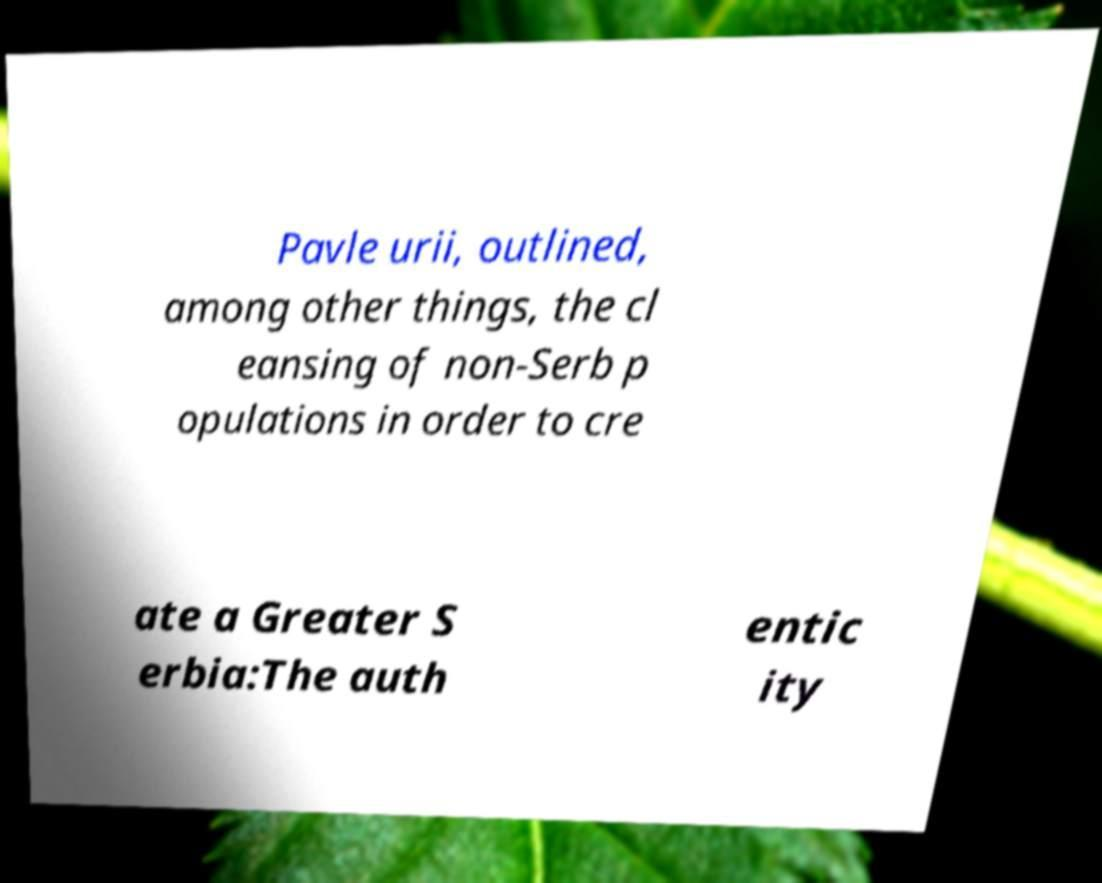I need the written content from this picture converted into text. Can you do that? Pavle urii, outlined, among other things, the cl eansing of non-Serb p opulations in order to cre ate a Greater S erbia:The auth entic ity 